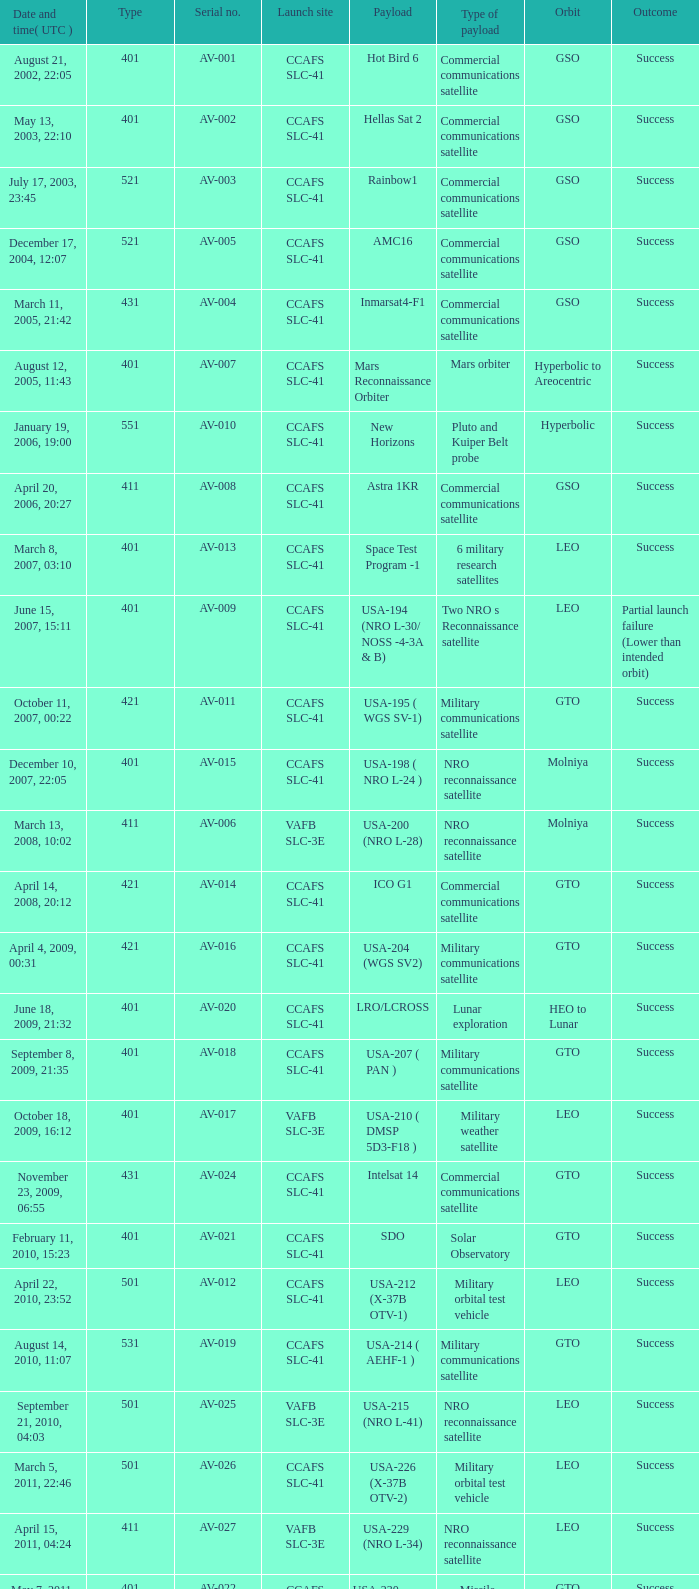Could you parse the entire table? {'header': ['Date and time( UTC )', 'Type', 'Serial no.', 'Launch site', 'Payload', 'Type of payload', 'Orbit', 'Outcome'], 'rows': [['August 21, 2002, 22:05', '401', 'AV-001', 'CCAFS SLC-41', 'Hot Bird 6', 'Commercial communications satellite', 'GSO', 'Success'], ['May 13, 2003, 22:10', '401', 'AV-002', 'CCAFS SLC-41', 'Hellas Sat 2', 'Commercial communications satellite', 'GSO', 'Success'], ['July 17, 2003, 23:45', '521', 'AV-003', 'CCAFS SLC-41', 'Rainbow1', 'Commercial communications satellite', 'GSO', 'Success'], ['December 17, 2004, 12:07', '521', 'AV-005', 'CCAFS SLC-41', 'AMC16', 'Commercial communications satellite', 'GSO', 'Success'], ['March 11, 2005, 21:42', '431', 'AV-004', 'CCAFS SLC-41', 'Inmarsat4-F1', 'Commercial communications satellite', 'GSO', 'Success'], ['August 12, 2005, 11:43', '401', 'AV-007', 'CCAFS SLC-41', 'Mars Reconnaissance Orbiter', 'Mars orbiter', 'Hyperbolic to Areocentric', 'Success'], ['January 19, 2006, 19:00', '551', 'AV-010', 'CCAFS SLC-41', 'New Horizons', 'Pluto and Kuiper Belt probe', 'Hyperbolic', 'Success'], ['April 20, 2006, 20:27', '411', 'AV-008', 'CCAFS SLC-41', 'Astra 1KR', 'Commercial communications satellite', 'GSO', 'Success'], ['March 8, 2007, 03:10', '401', 'AV-013', 'CCAFS SLC-41', 'Space Test Program -1', '6 military research satellites', 'LEO', 'Success'], ['June 15, 2007, 15:11', '401', 'AV-009', 'CCAFS SLC-41', 'USA-194 (NRO L-30/ NOSS -4-3A & B)', 'Two NRO s Reconnaissance satellite', 'LEO', 'Partial launch failure (Lower than intended orbit)'], ['October 11, 2007, 00:22', '421', 'AV-011', 'CCAFS SLC-41', 'USA-195 ( WGS SV-1)', 'Military communications satellite', 'GTO', 'Success'], ['December 10, 2007, 22:05', '401', 'AV-015', 'CCAFS SLC-41', 'USA-198 ( NRO L-24 )', 'NRO reconnaissance satellite', 'Molniya', 'Success'], ['March 13, 2008, 10:02', '411', 'AV-006', 'VAFB SLC-3E', 'USA-200 (NRO L-28)', 'NRO reconnaissance satellite', 'Molniya', 'Success'], ['April 14, 2008, 20:12', '421', 'AV-014', 'CCAFS SLC-41', 'ICO G1', 'Commercial communications satellite', 'GTO', 'Success'], ['April 4, 2009, 00:31', '421', 'AV-016', 'CCAFS SLC-41', 'USA-204 (WGS SV2)', 'Military communications satellite', 'GTO', 'Success'], ['June 18, 2009, 21:32', '401', 'AV-020', 'CCAFS SLC-41', 'LRO/LCROSS', 'Lunar exploration', 'HEO to Lunar', 'Success'], ['September 8, 2009, 21:35', '401', 'AV-018', 'CCAFS SLC-41', 'USA-207 ( PAN )', 'Military communications satellite', 'GTO', 'Success'], ['October 18, 2009, 16:12', '401', 'AV-017', 'VAFB SLC-3E', 'USA-210 ( DMSP 5D3-F18 )', 'Military weather satellite', 'LEO', 'Success'], ['November 23, 2009, 06:55', '431', 'AV-024', 'CCAFS SLC-41', 'Intelsat 14', 'Commercial communications satellite', 'GTO', 'Success'], ['February 11, 2010, 15:23', '401', 'AV-021', 'CCAFS SLC-41', 'SDO', 'Solar Observatory', 'GTO', 'Success'], ['April 22, 2010, 23:52', '501', 'AV-012', 'CCAFS SLC-41', 'USA-212 (X-37B OTV-1)', 'Military orbital test vehicle', 'LEO', 'Success'], ['August 14, 2010, 11:07', '531', 'AV-019', 'CCAFS SLC-41', 'USA-214 ( AEHF-1 )', 'Military communications satellite', 'GTO', 'Success'], ['September 21, 2010, 04:03', '501', 'AV-025', 'VAFB SLC-3E', 'USA-215 (NRO L-41)', 'NRO reconnaissance satellite', 'LEO', 'Success'], ['March 5, 2011, 22:46', '501', 'AV-026', 'CCAFS SLC-41', 'USA-226 (X-37B OTV-2)', 'Military orbital test vehicle', 'LEO', 'Success'], ['April 15, 2011, 04:24', '411', 'AV-027', 'VAFB SLC-3E', 'USA-229 (NRO L-34)', 'NRO reconnaissance satellite', 'LEO', 'Success'], ['May 7, 2011, 18:10', '401', 'AV-022', 'CCAFS SLC-41', 'USA-230 (SBIRS-GEO-1)', 'Missile Warning satellite', 'GTO', 'Success'], ['August 5, 2011, 16:25', '551', 'AV-029', 'CCAFS SLC-41', 'Juno', 'Jupiter orbiter', 'Hyperbolic to Jovicentric', 'Success'], ['November 26, 2011, 15:02', '541', 'AV-028', 'CCAFS SLC-41', 'Mars Science Laboratory', 'Mars rover', 'Hyperbolic (Mars landing)', 'Success'], ['February 24, 2012, 22:15', '551', 'AV-030', 'CCAFS SLC-41', 'MUOS-1', 'Military communications satellite', 'GTO', 'Success'], ['May 4, 2012, 18:42', '531', 'AV-031', 'CCAFS SLC-41', 'USA-235 ( AEHF-2 )', 'Military communications satellite', 'GTO', 'Success'], ['June 20, 2012, 12:28', '401', 'AV-023', 'CCAFS SLC-41', 'USA-236 (NROL-38)', 'NRO reconnaissance satellite', 'GEO', 'Success'], ['August 30, 2012, 08:05', '401', 'AV-032', 'CCAFS SLC-41', 'Van Allen Probes (RBSP)', 'Van Allen Belts exploration', 'MEO', 'Success'], ['September 13, 2012, 21:39', '401', 'AV-033', 'VAFB SLC-3E', 'USA-238 (NROL-36)', 'NRO reconnaissance satellites', 'LEO', 'Success'], ['December 11, 2012, 18:03', '501', 'AV-034', 'CCAFS SLC-41', 'USA-240 (X-37B OTV-3)', 'Military orbital test vehicle', 'LEO', 'Success'], ['January 31, 2013, 01:48', '401', 'AV-036', 'CCAFS SLC-41', 'TDRS-11 (TDRS-K)', 'Data relay satellite', 'GTO', 'Success'], ['February 11, 2013, 18:02', '401', 'AV-035', 'VAFB SLC-3E', 'Landsat 8', 'Earth Observation satellite', 'LEO', 'Success'], ['March 19, 2013, 21:21', '401', 'AV-037', 'CCAFS SLC-41', 'USA-241 ( SBIRS-GEO 2 )', 'Missile Warning satellite', 'GTO', 'Success'], ['May 15, 2013, 21:38', '401', 'AV-039', 'CCAFS SLC-41', 'USA-242 ( GPS IIF-4 )', 'Navigation satellite', 'MEO', 'Success'], ['July 19, 2013, 13:00', '551', 'AV-040', 'CCAFS SLC-41', 'MUOS-2', 'Military Communications satellite', 'GTO', 'Success'], ['September 18, 2013, 08:10', '531', 'AV-041', 'CCAFS SLC-41', 'USA-246 (AEHF-3)', 'Military communications satellite', 'GTO', 'Success']]} What load was carried on november 26, 2011, 15:02? Mars rover. 